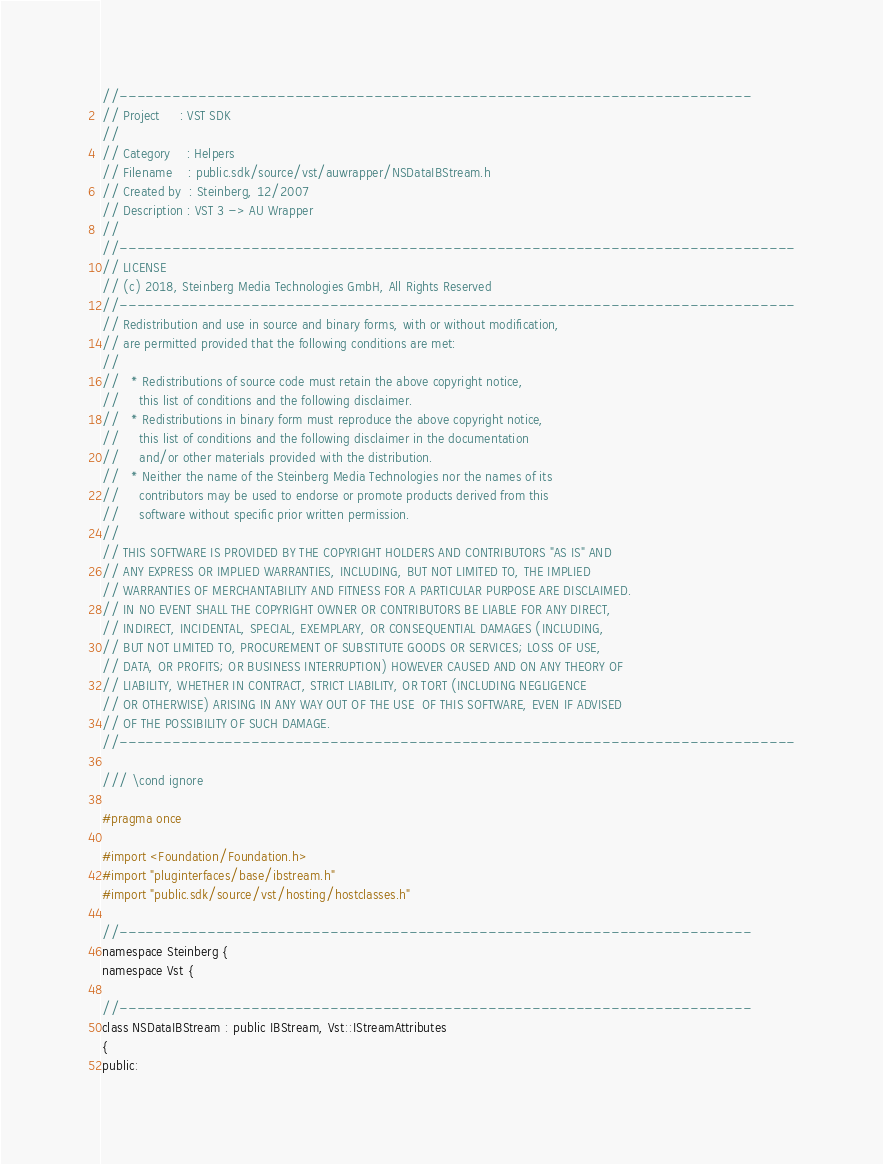<code> <loc_0><loc_0><loc_500><loc_500><_C_>//------------------------------------------------------------------------
// Project     : VST SDK
//
// Category    : Helpers
// Filename    : public.sdk/source/vst/auwrapper/NSDataIBStream.h
// Created by  : Steinberg, 12/2007
// Description : VST 3 -> AU Wrapper
//
//-----------------------------------------------------------------------------
// LICENSE
// (c) 2018, Steinberg Media Technologies GmbH, All Rights Reserved
//-----------------------------------------------------------------------------
// Redistribution and use in source and binary forms, with or without modification,
// are permitted provided that the following conditions are met:
// 
//   * Redistributions of source code must retain the above copyright notice, 
//     this list of conditions and the following disclaimer.
//   * Redistributions in binary form must reproduce the above copyright notice,
//     this list of conditions and the following disclaimer in the documentation 
//     and/or other materials provided with the distribution.
//   * Neither the name of the Steinberg Media Technologies nor the names of its
//     contributors may be used to endorse or promote products derived from this 
//     software without specific prior written permission.
// 
// THIS SOFTWARE IS PROVIDED BY THE COPYRIGHT HOLDERS AND CONTRIBUTORS "AS IS" AND
// ANY EXPRESS OR IMPLIED WARRANTIES, INCLUDING, BUT NOT LIMITED TO, THE IMPLIED 
// WARRANTIES OF MERCHANTABILITY AND FITNESS FOR A PARTICULAR PURPOSE ARE DISCLAIMED. 
// IN NO EVENT SHALL THE COPYRIGHT OWNER OR CONTRIBUTORS BE LIABLE FOR ANY DIRECT, 
// INDIRECT, INCIDENTAL, SPECIAL, EXEMPLARY, OR CONSEQUENTIAL DAMAGES (INCLUDING, 
// BUT NOT LIMITED TO, PROCUREMENT OF SUBSTITUTE GOODS OR SERVICES; LOSS OF USE, 
// DATA, OR PROFITS; OR BUSINESS INTERRUPTION) HOWEVER CAUSED AND ON ANY THEORY OF 
// LIABILITY, WHETHER IN CONTRACT, STRICT LIABILITY, OR TORT (INCLUDING NEGLIGENCE 
// OR OTHERWISE) ARISING IN ANY WAY OUT OF THE USE  OF THIS SOFTWARE, EVEN IF ADVISED
// OF THE POSSIBILITY OF SUCH DAMAGE.
//-----------------------------------------------------------------------------

/// \cond ignore

#pragma once

#import <Foundation/Foundation.h>
#import "pluginterfaces/base/ibstream.h"
#import "public.sdk/source/vst/hosting/hostclasses.h"

//------------------------------------------------------------------------
namespace Steinberg {
namespace Vst {

//------------------------------------------------------------------------
class NSDataIBStream : public IBStream, Vst::IStreamAttributes
{
public:</code> 